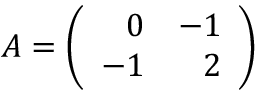Convert formula to latex. <formula><loc_0><loc_0><loc_500><loc_500>A = \left ( \begin{array} { r r } { 0 } & { - 1 } \\ { - 1 } & { 2 } \end{array} \right )</formula> 